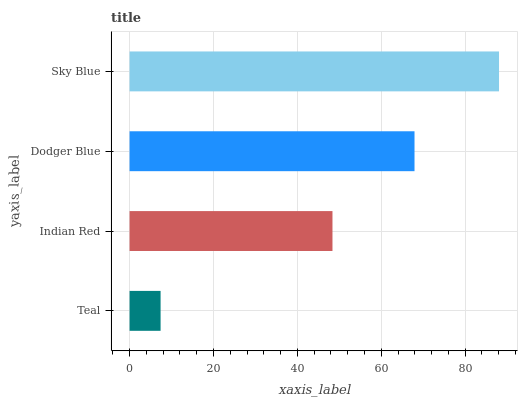Is Teal the minimum?
Answer yes or no. Yes. Is Sky Blue the maximum?
Answer yes or no. Yes. Is Indian Red the minimum?
Answer yes or no. No. Is Indian Red the maximum?
Answer yes or no. No. Is Indian Red greater than Teal?
Answer yes or no. Yes. Is Teal less than Indian Red?
Answer yes or no. Yes. Is Teal greater than Indian Red?
Answer yes or no. No. Is Indian Red less than Teal?
Answer yes or no. No. Is Dodger Blue the high median?
Answer yes or no. Yes. Is Indian Red the low median?
Answer yes or no. Yes. Is Indian Red the high median?
Answer yes or no. No. Is Dodger Blue the low median?
Answer yes or no. No. 